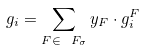<formula> <loc_0><loc_0><loc_500><loc_500>g _ { i } = \sum _ { F \in \ F _ { \sigma } } y _ { F } \cdot g _ { i } ^ { F }</formula> 